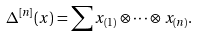<formula> <loc_0><loc_0><loc_500><loc_500>\Delta ^ { [ n ] } ( x ) = \sum x _ { ( 1 ) } \otimes \cdots \otimes x _ { ( n ) } .</formula> 